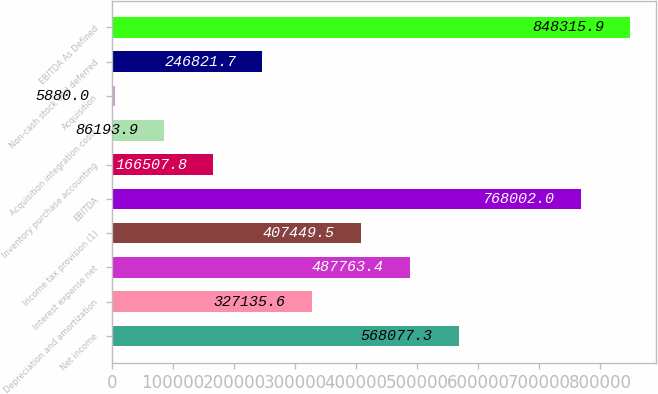Convert chart. <chart><loc_0><loc_0><loc_500><loc_500><bar_chart><fcel>Net income<fcel>Depreciation and amortization<fcel>Interest expense net<fcel>Income tax provision (1)<fcel>EBITDA<fcel>Inventory purchase accounting<fcel>Acquisition integration costs<fcel>Acquisition<fcel>Non-cash stock and deferred<fcel>EBITDA As Defined<nl><fcel>568077<fcel>327136<fcel>487763<fcel>407450<fcel>768002<fcel>166508<fcel>86193.9<fcel>5880<fcel>246822<fcel>848316<nl></chart> 